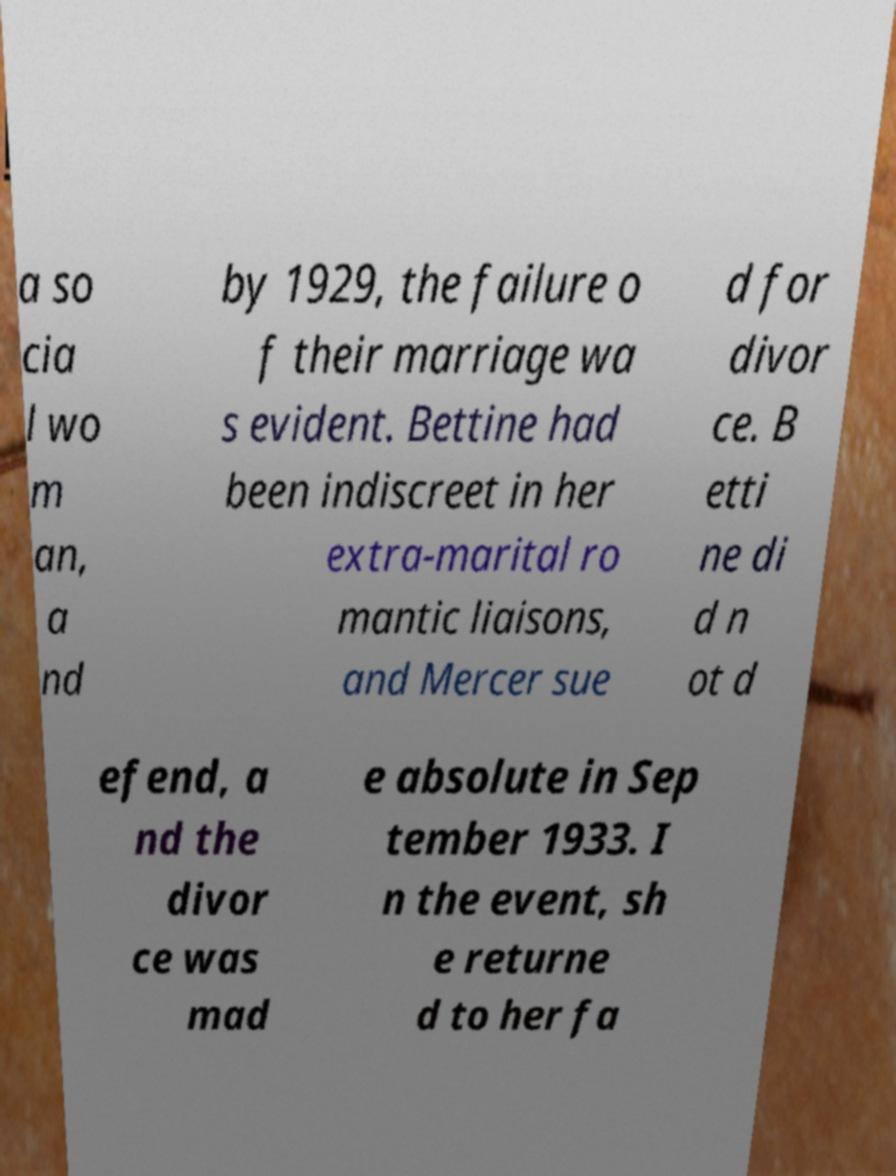Can you accurately transcribe the text from the provided image for me? a so cia l wo m an, a nd by 1929, the failure o f their marriage wa s evident. Bettine had been indiscreet in her extra-marital ro mantic liaisons, and Mercer sue d for divor ce. B etti ne di d n ot d efend, a nd the divor ce was mad e absolute in Sep tember 1933. I n the event, sh e returne d to her fa 